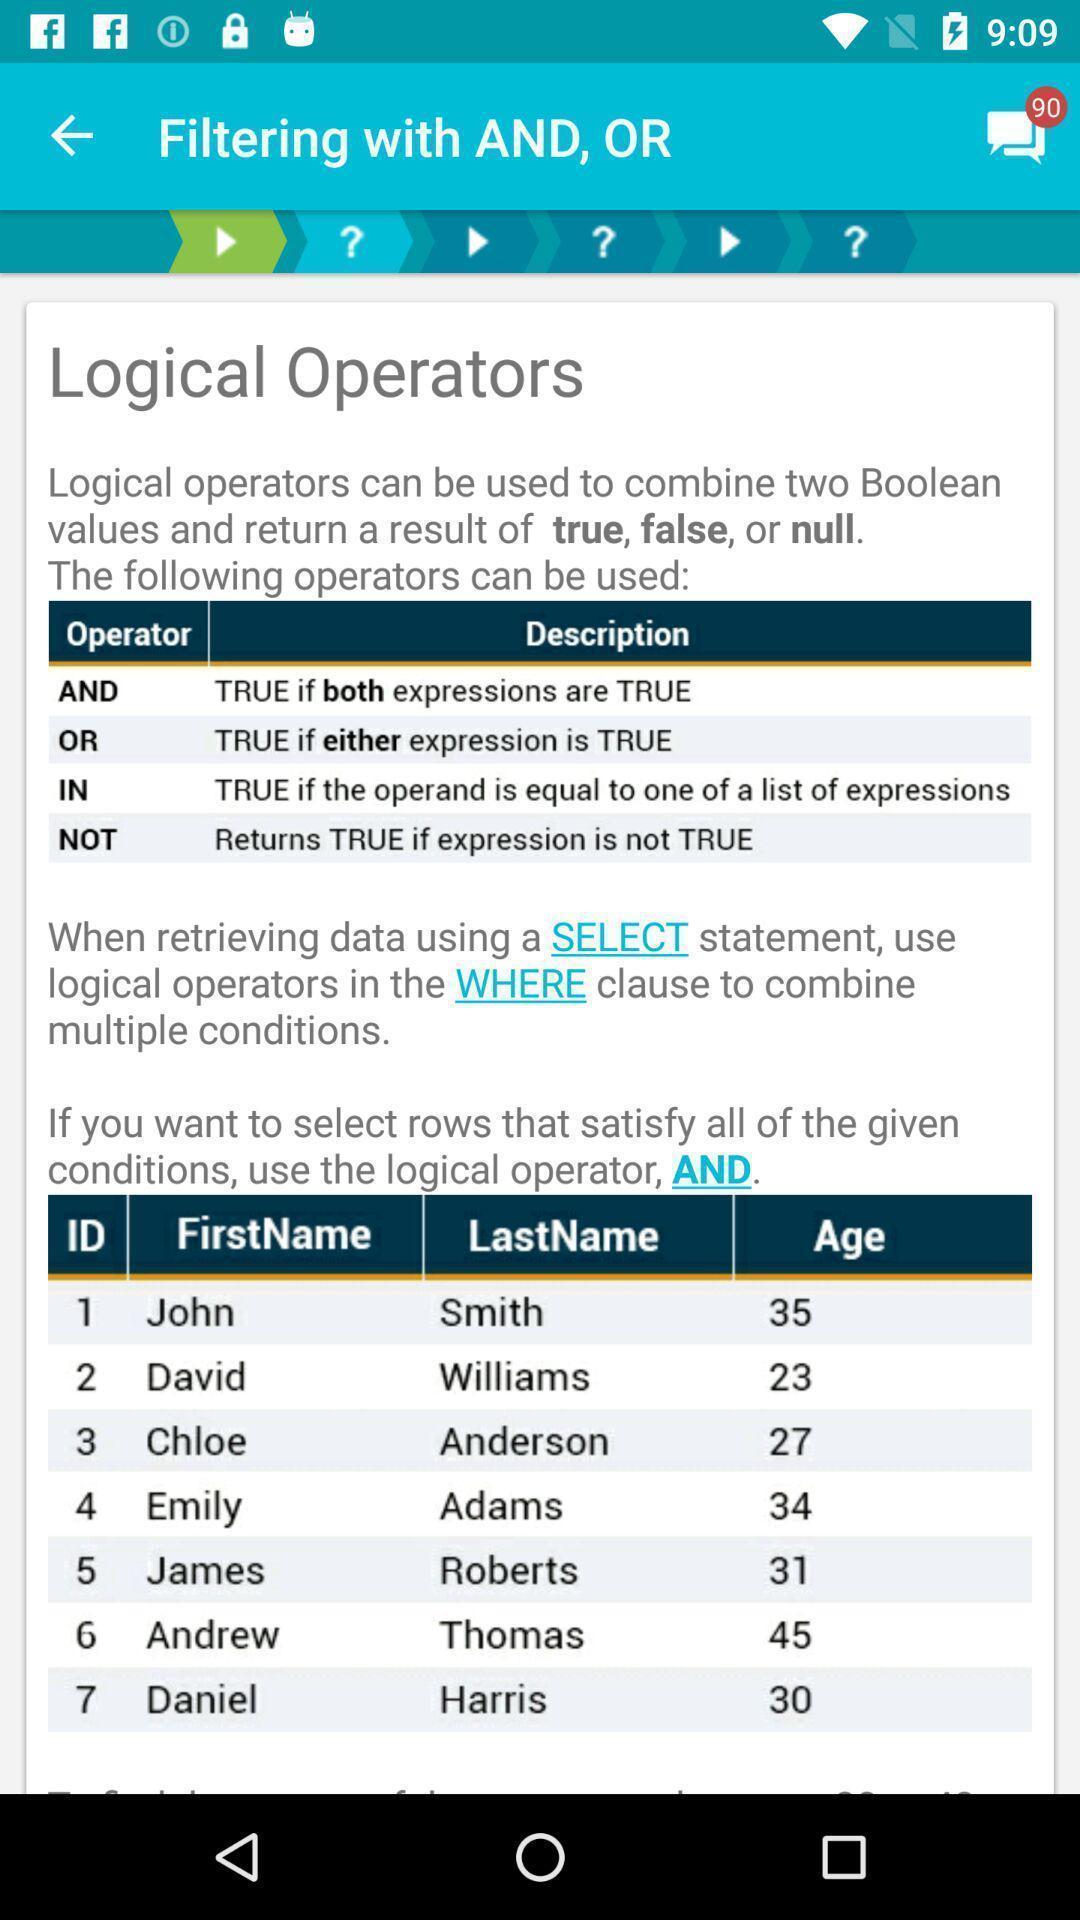Explain the elements present in this screenshot. Screen page showing information in learning application. 